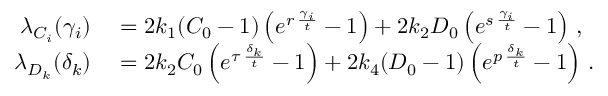<formula> <loc_0><loc_0><loc_500><loc_500>\begin{array} { r l } { \lambda _ { C _ { i } } ( \gamma _ { i } ) } & = 2 k _ { 1 } ( C _ { 0 } - 1 ) \left ( e ^ { r \, \frac { \gamma _ { i } } { t } } - 1 \right ) + 2 k _ { 2 } D _ { 0 } \left ( e ^ { s \, \frac { \gamma _ { i } } { t } } - 1 \right ) \, , } \\ { \lambda _ { D _ { k } } ( \delta _ { k } ) } & = 2 k _ { 2 } C _ { 0 } \left ( e ^ { \tau \, \frac { \delta _ { k } } { t } } - 1 \right ) + 2 k _ { 4 } ( D _ { 0 } - 1 ) \left ( e ^ { p \, \frac { \delta _ { k } } { t } } - 1 \right ) \, . } \end{array}</formula> 